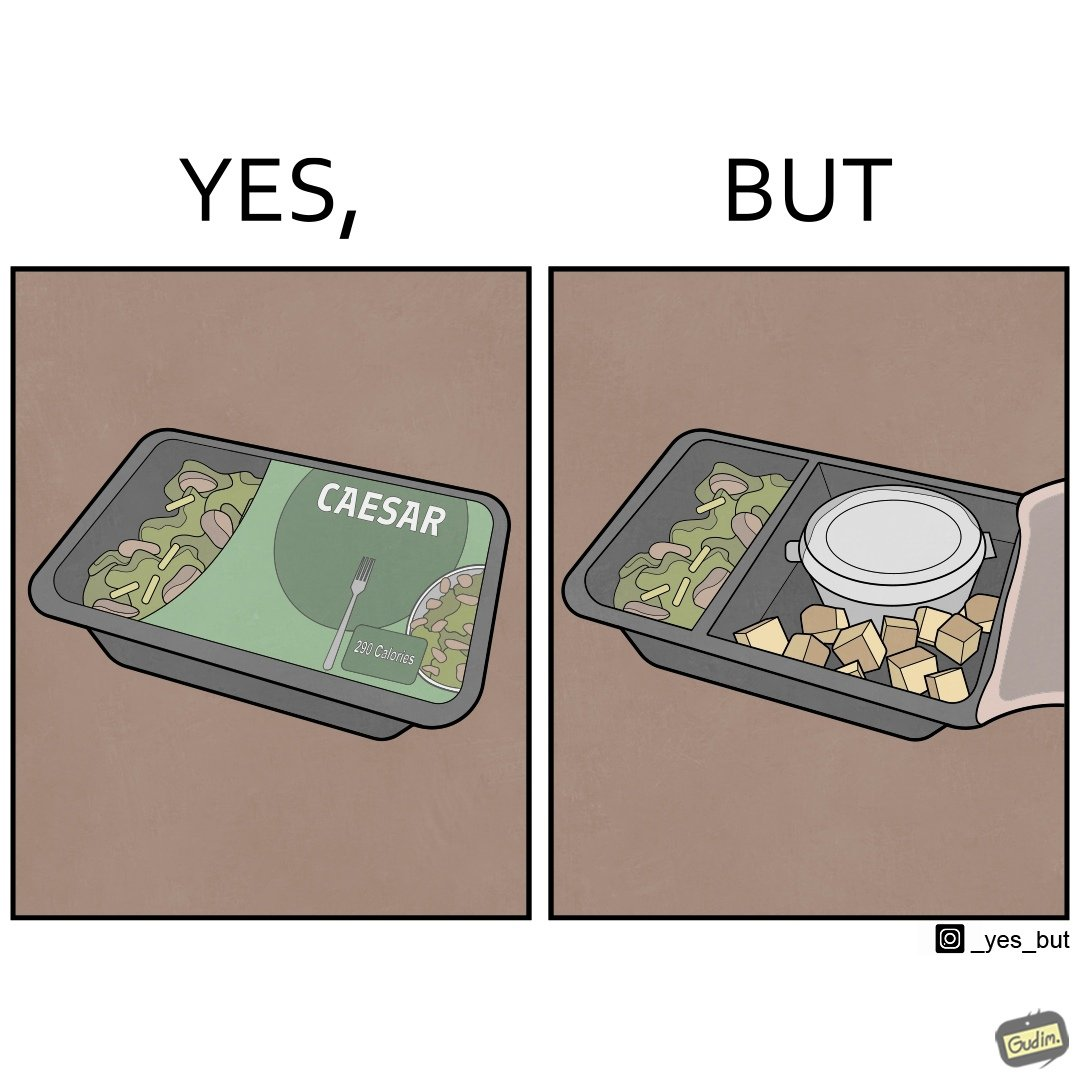What makes this image funny or satirical? Image is funny because the box of salad was marketed in a way that showed a lot more salad content than was really present inside it. 